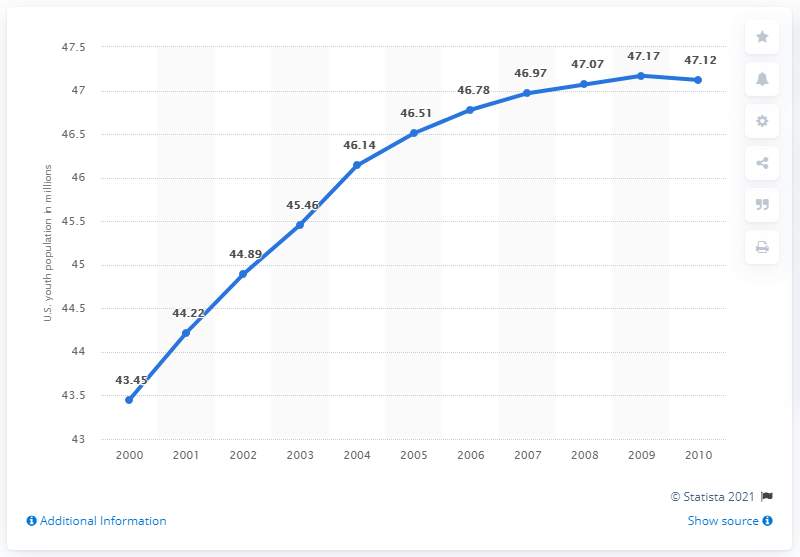Is the growth rate constant or does it fluctuate over the years? The growth rate appears to fluctuate slightly over the years. For instance, the years from 2000 to 2001 show a smaller increase compared to more substantial growth in later years, such as from 2007 to 2008. 